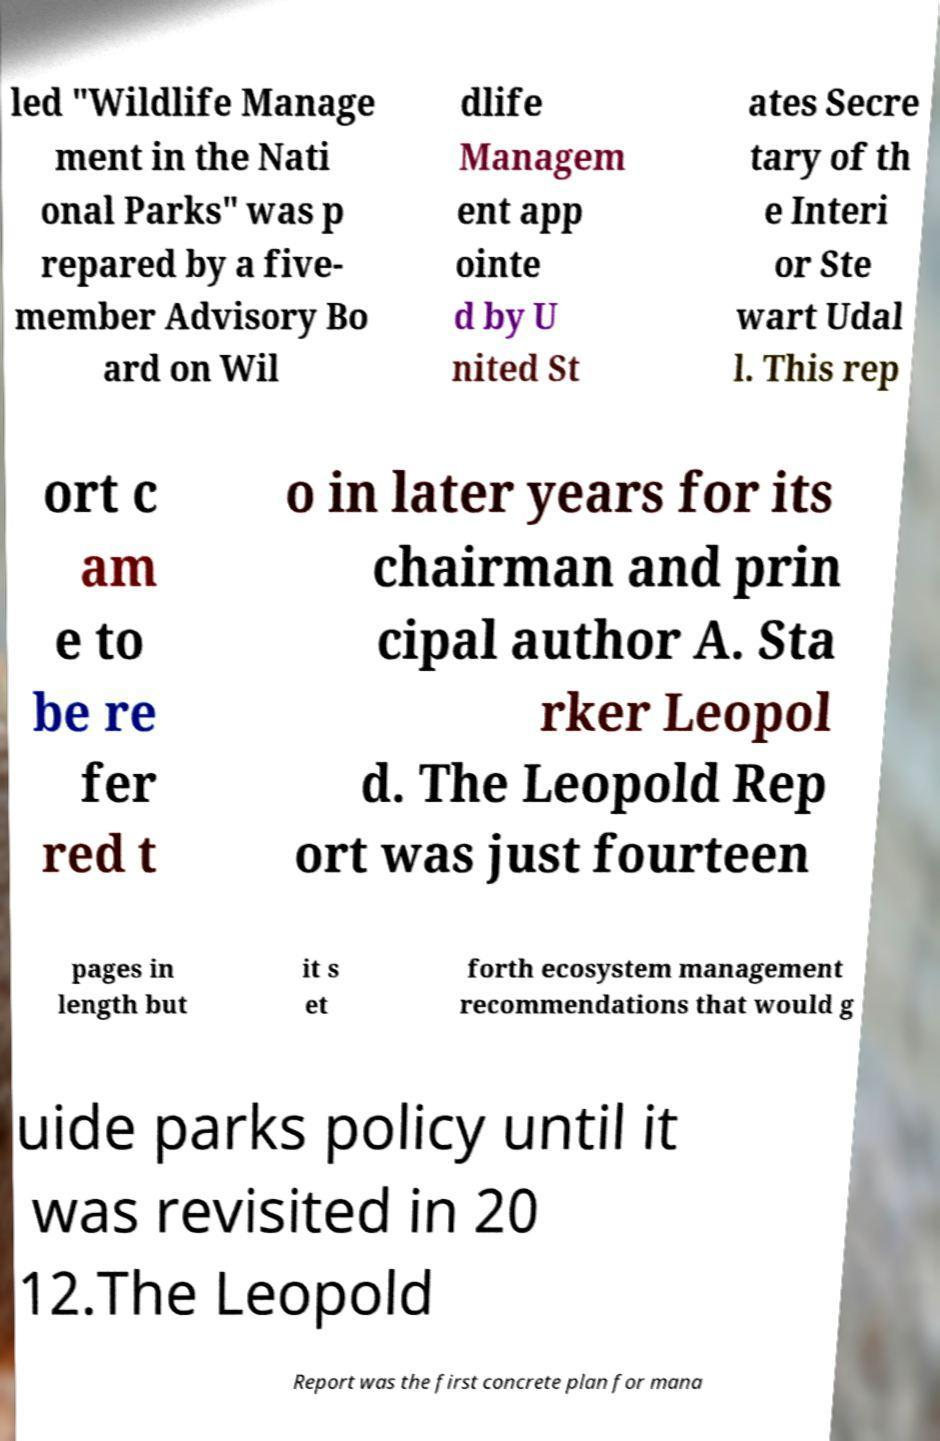Could you assist in decoding the text presented in this image and type it out clearly? led "Wildlife Manage ment in the Nati onal Parks" was p repared by a five- member Advisory Bo ard on Wil dlife Managem ent app ointe d by U nited St ates Secre tary of th e Interi or Ste wart Udal l. This rep ort c am e to be re fer red t o in later years for its chairman and prin cipal author A. Sta rker Leopol d. The Leopold Rep ort was just fourteen pages in length but it s et forth ecosystem management recommendations that would g uide parks policy until it was revisited in 20 12.The Leopold Report was the first concrete plan for mana 